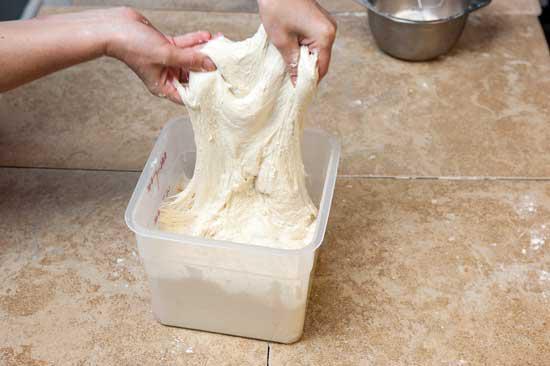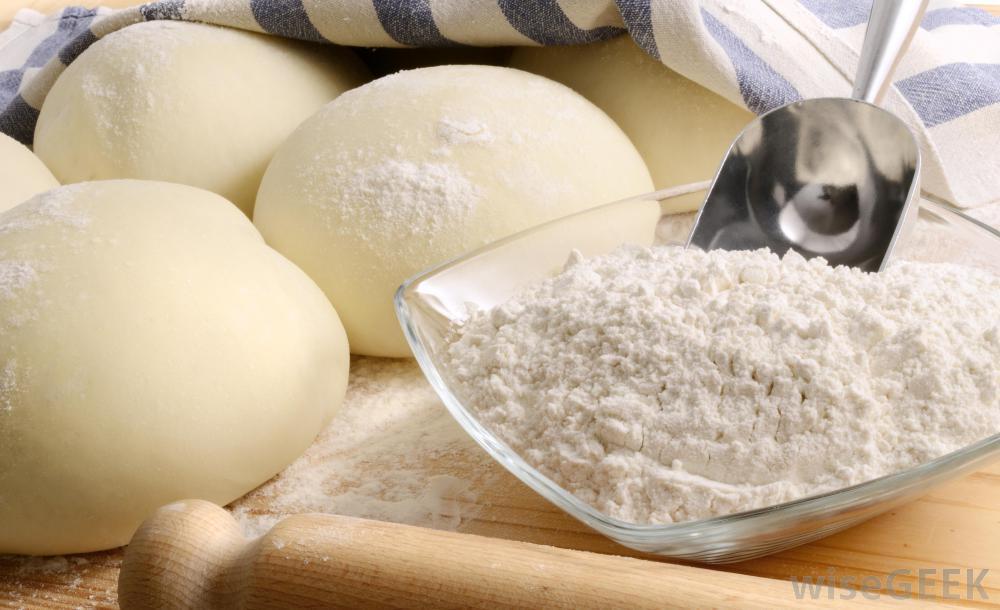The first image is the image on the left, the second image is the image on the right. Analyze the images presented: Is the assertion "In one of the images, dough is being transferred out of a ceramic container." valid? Answer yes or no. No. The first image is the image on the left, the second image is the image on the right. Analyze the images presented: Is the assertion "The combined images show a mound of dough on a floured wooden counter and dough being dumped out of a loaf pan with ribbed texture." valid? Answer yes or no. No. 